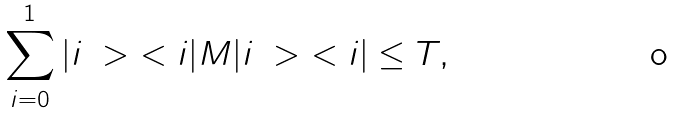Convert formula to latex. <formula><loc_0><loc_0><loc_500><loc_500>\sum _ { i = 0 } ^ { 1 } | i \ > \ < i | M | i \ > \ < i | \leq T ,</formula> 